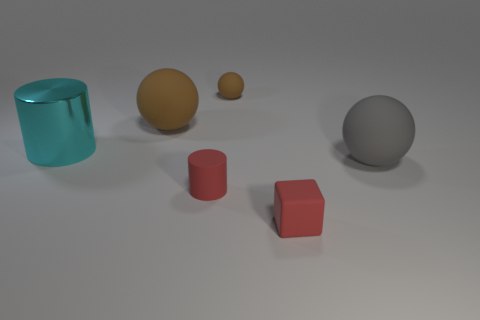Add 3 tiny rubber cubes. How many objects exist? 9 Subtract all cubes. How many objects are left? 5 Add 5 red cylinders. How many red cylinders are left? 6 Add 6 small gray metal objects. How many small gray metal objects exist? 6 Subtract 0 blue cylinders. How many objects are left? 6 Subtract all big gray rubber blocks. Subtract all red rubber cylinders. How many objects are left? 5 